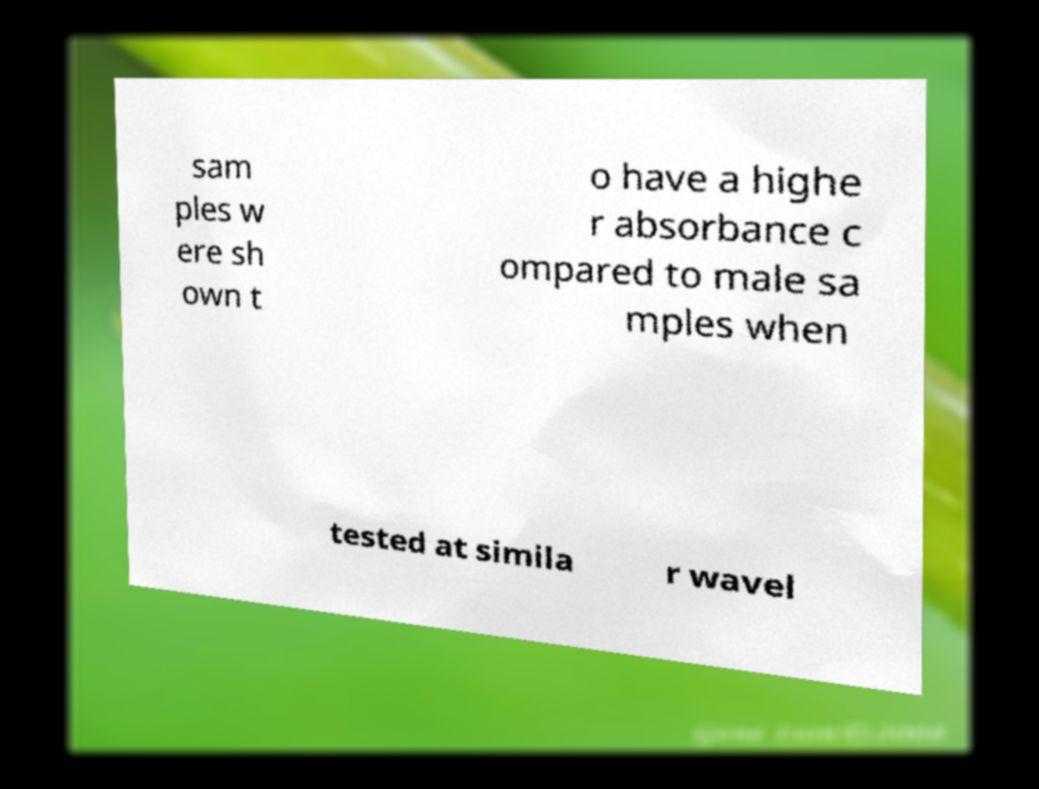I need the written content from this picture converted into text. Can you do that? sam ples w ere sh own t o have a highe r absorbance c ompared to male sa mples when tested at simila r wavel 